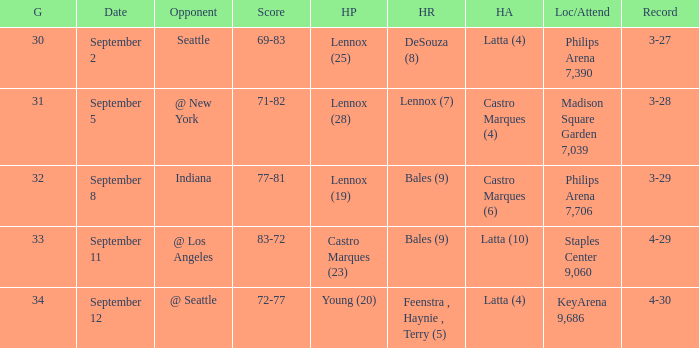When did indiana play? September 8. 